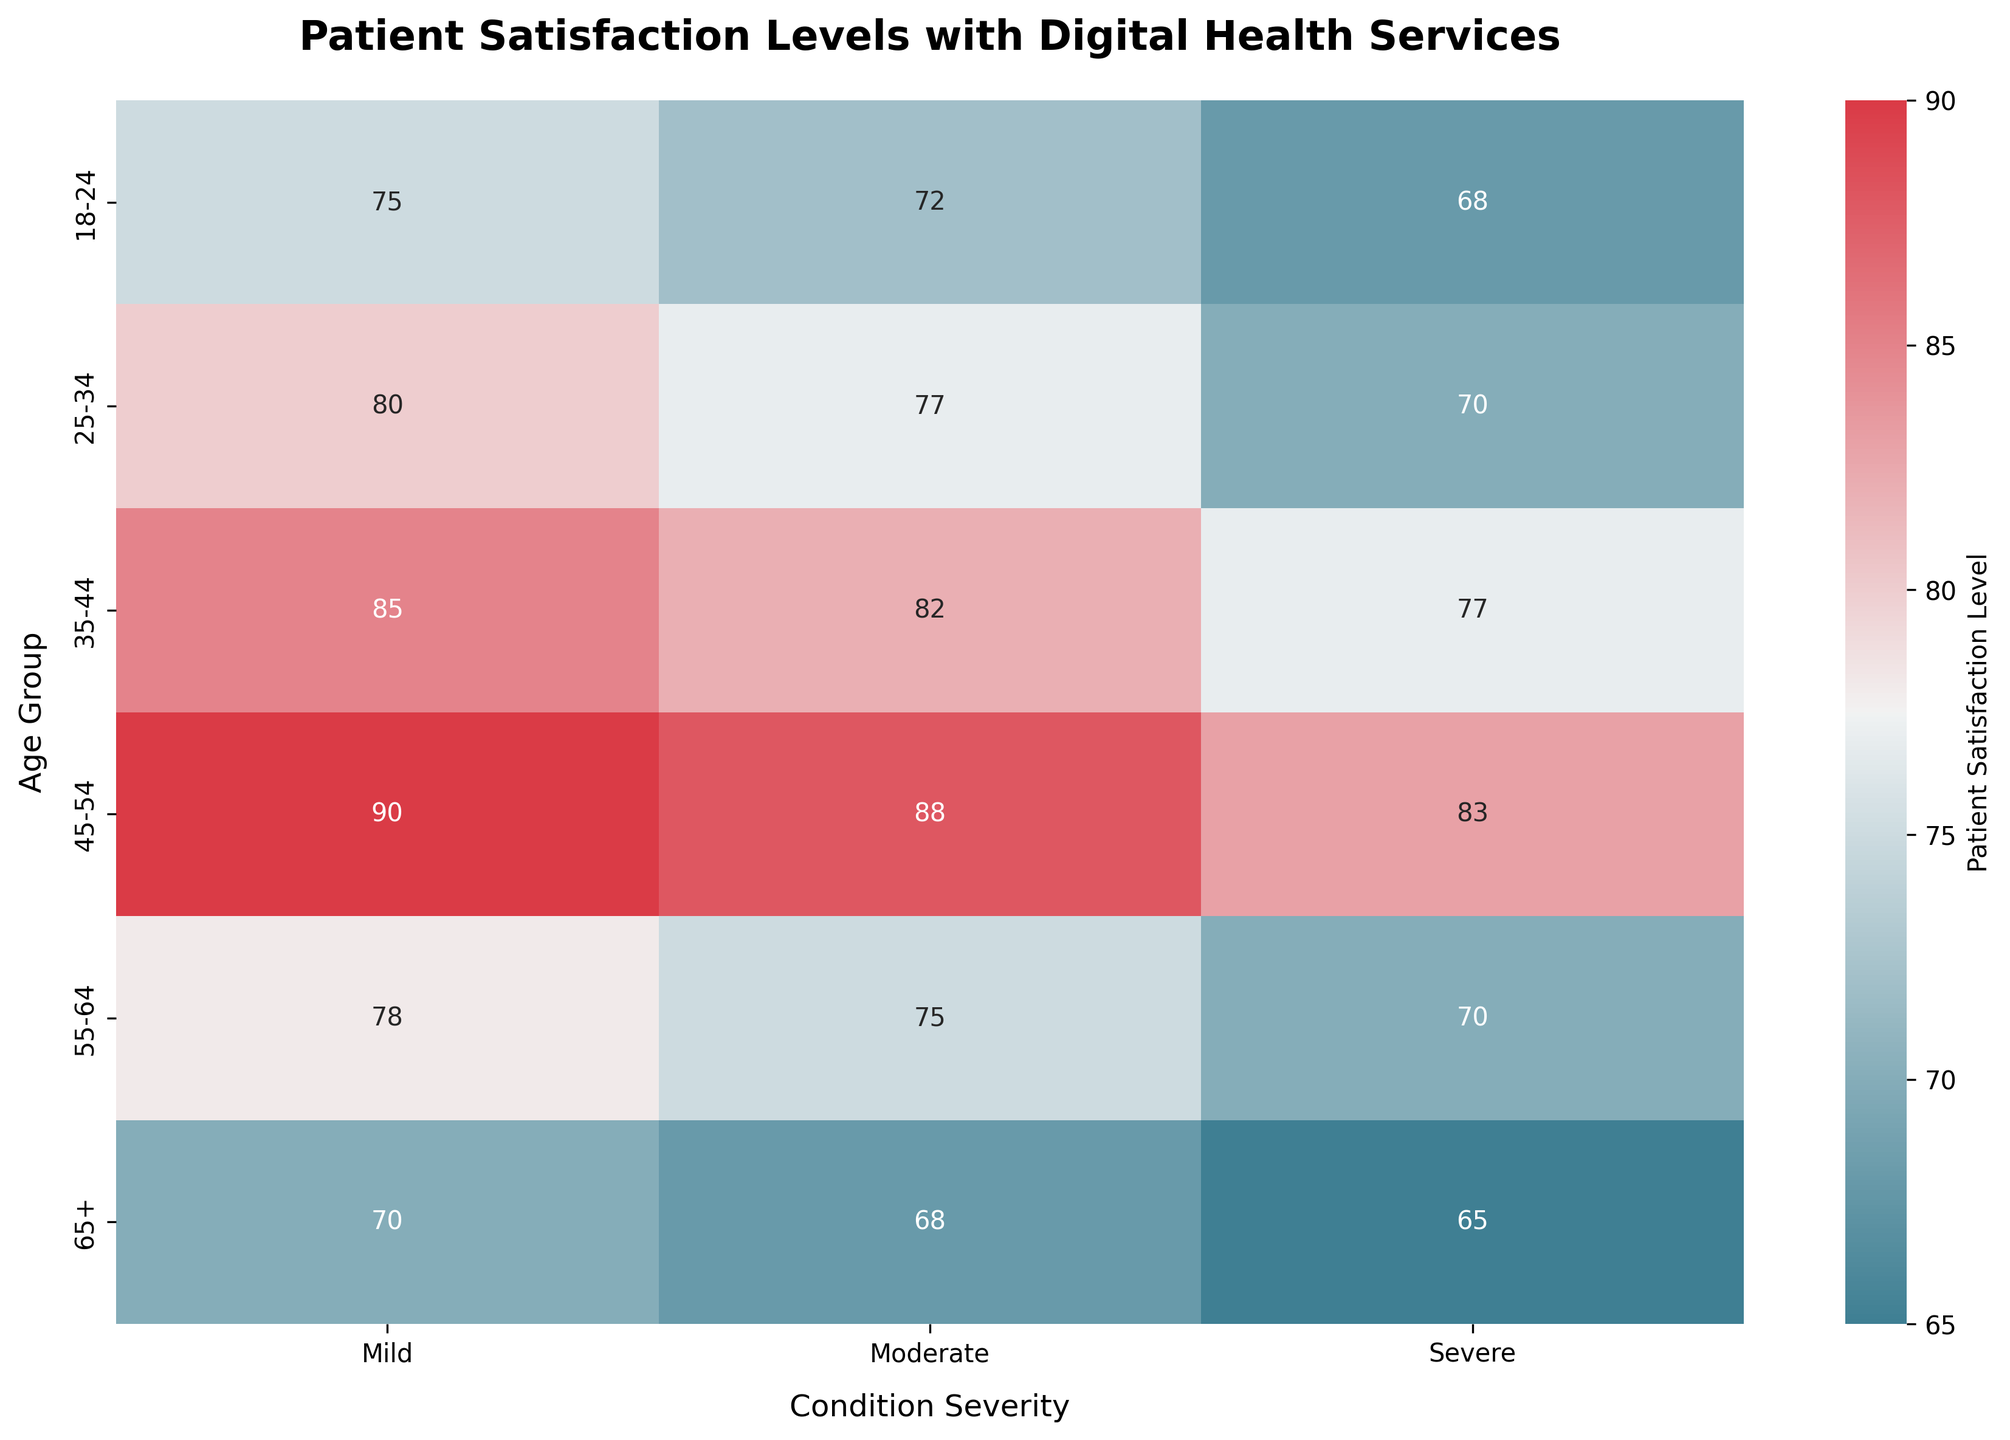What's the title of the heatmap? The title of the heatmap is present at the top of the figure. It reads "Patient Satisfaction Levels with Digital Health Services".
Answer: Patient Satisfaction Levels with Digital Health Services Which age group has the highest satisfaction level for severe condition severity? To find this, look at the row corresponding to each age group and check the values under the "Severe" column. The highest value in this column is 83 for the 45-54 age group.
Answer: 45-54 What is the satisfaction level for the 65+ age group with mild condition severity? Locate the row for the 65+ age group and check the value under the "Mild" column. The satisfaction level is 70.
Answer: 70 Which condition severity has the highest patient satisfaction level across all age groups? To determine this, you need to look at the maximum values in each column. The highest value, 90, appears in the "Mild" column.
Answer: Mild What is the average satisfaction level for the 35-44 age group across all condition severities? Add the satisfaction levels for the 35-44 age group: 85 (Mild) + 82 (Moderate) + 77 (Severe) = 244. Then divide by 3 (the number of data points). The average satisfaction level is 244 / 3 = 81.3.
Answer: 81.3 How does the satisfaction level for moderate conditions in the 25-34 age group compare to the 55-64 age group? Look at the "Moderate" column for both age groups. The 25-34 age group has a satisfaction level of 77, while the 55-64 age group has a satisfaction level of 75. Therefore, 77 is greater than 75.
Answer: 77 is greater than 75 What is the overall range of satisfaction levels for patients aged 18-24? To find the range, identify the minimum and maximum satisfaction levels for the 18-24 age group: minimum is 68 (Severe) and maximum is 75 (Mild). The range is 75 - 68 = 7.
Answer: 7 Which two age groups have the closest satisfaction levels for mild condition severity, and what are their levels? Look at the values in the "Mild" column. 25-34 has 80 and 55-64 has 78. The difference is just 2, which is the smallest difference between any two levels for mild condition severity.
Answer: 25-34 (80) and 55-64 (78) Is there a consistent trend in satisfaction levels based on age groups for severe condition severity? Examine the "Severe" column; notice that the satisfaction levels generally decrease as age increases from 18-24 (68) to 65+ (65), with a peak at 45-54 (83). This suggests there isn't a strictly consistent trend.
Answer: No consistent trend 